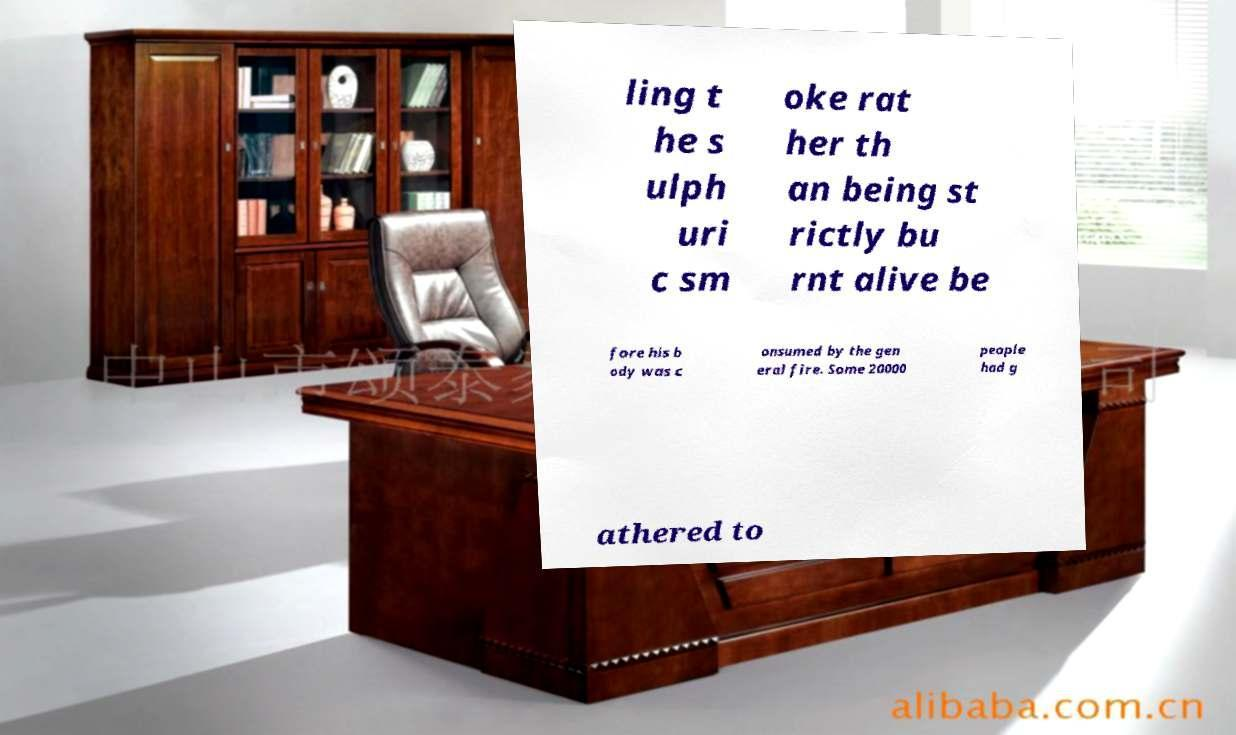Could you extract and type out the text from this image? ling t he s ulph uri c sm oke rat her th an being st rictly bu rnt alive be fore his b ody was c onsumed by the gen eral fire. Some 20000 people had g athered to 